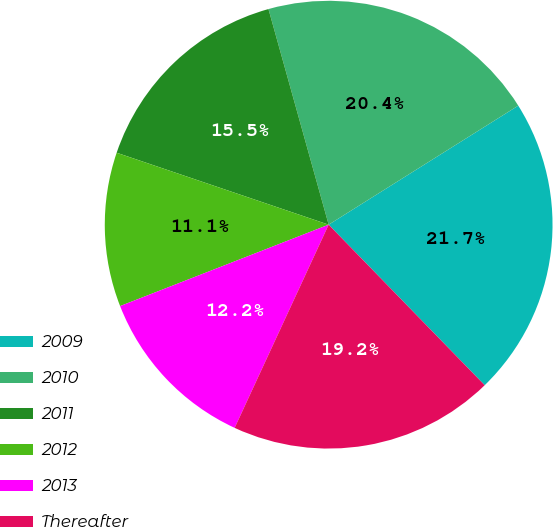Convert chart to OTSL. <chart><loc_0><loc_0><loc_500><loc_500><pie_chart><fcel>2009<fcel>2010<fcel>2011<fcel>2012<fcel>2013<fcel>Thereafter<nl><fcel>21.65%<fcel>20.41%<fcel>15.46%<fcel>11.13%<fcel>12.18%<fcel>19.17%<nl></chart> 